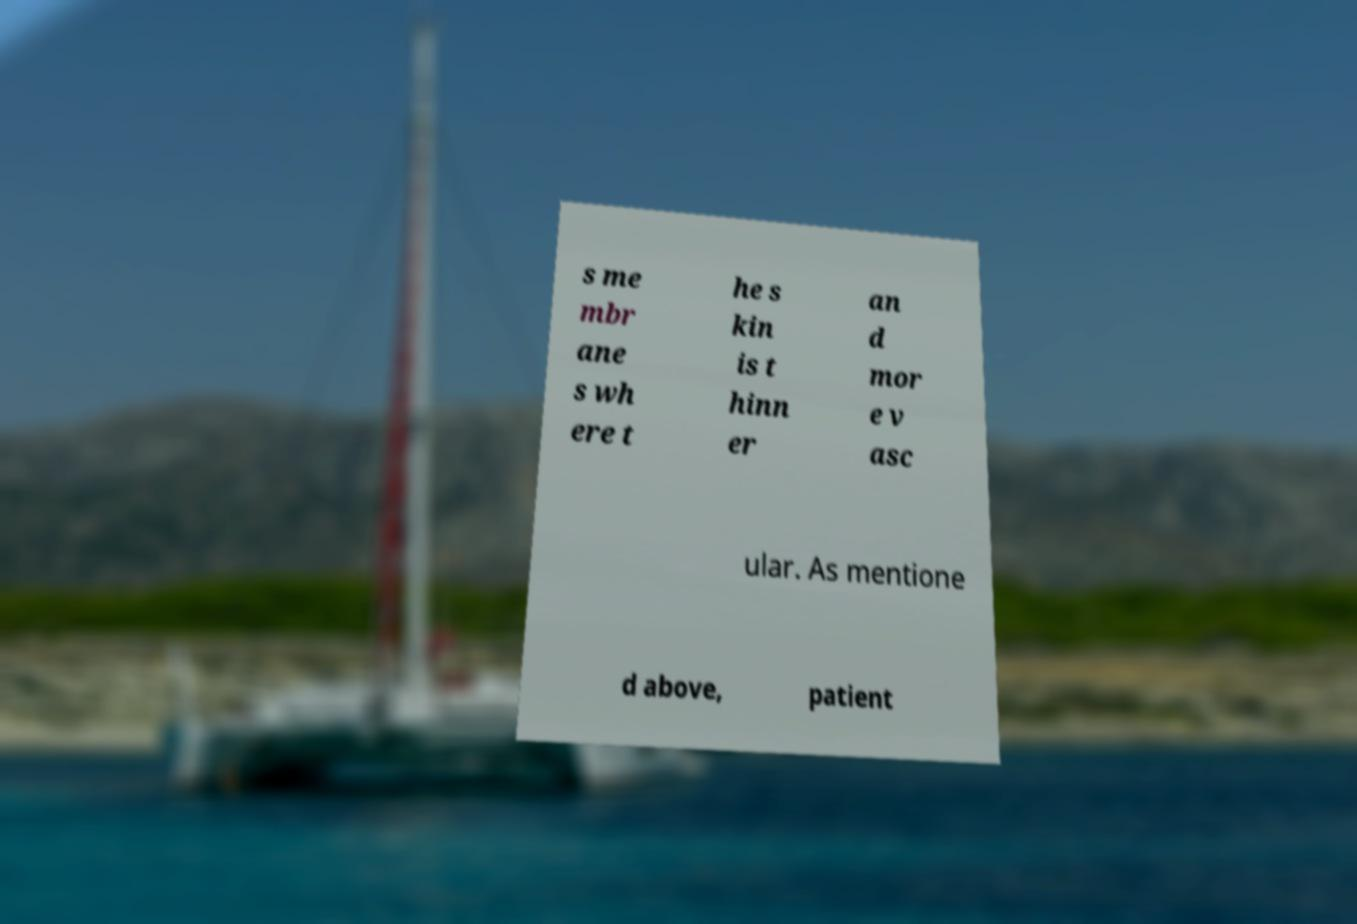What messages or text are displayed in this image? I need them in a readable, typed format. s me mbr ane s wh ere t he s kin is t hinn er an d mor e v asc ular. As mentione d above, patient 